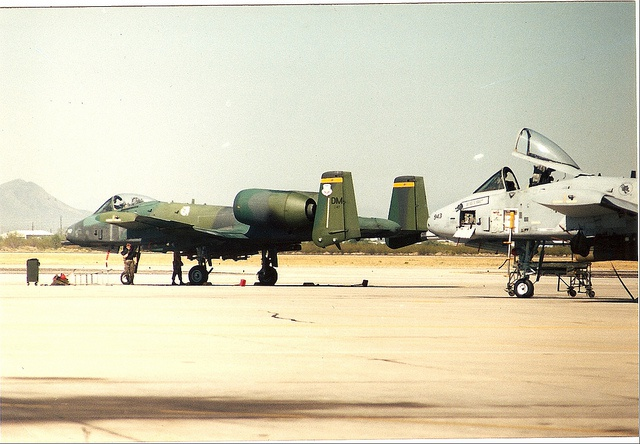Describe the objects in this image and their specific colors. I can see airplane in white, black, gray, olive, and darkgreen tones, airplane in white, beige, black, and darkgray tones, people in white, black, beige, gray, and darkgray tones, and people in white, black, gray, and maroon tones in this image. 